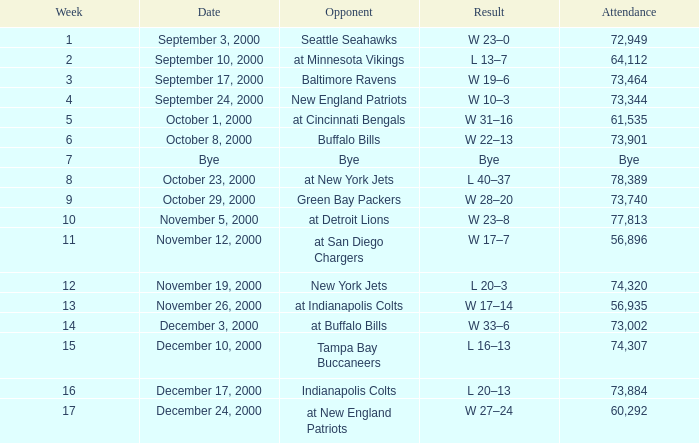What is the Result of the game with 72,949 in attendance? W 23–0. 